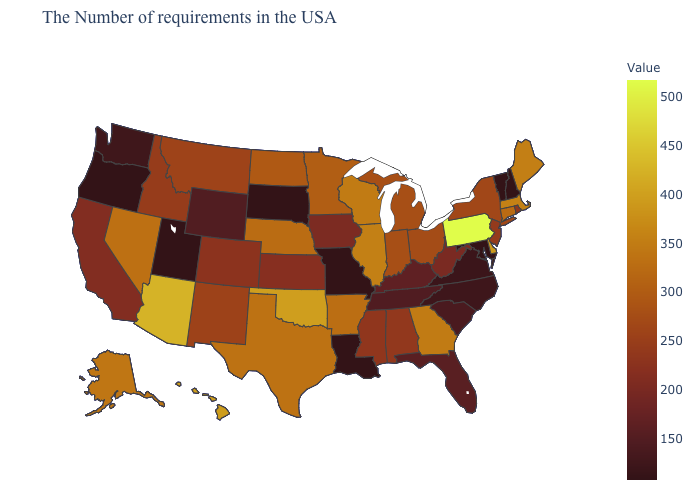Does the map have missing data?
Give a very brief answer. No. Which states have the lowest value in the Northeast?
Concise answer only. New Hampshire, Vermont. Does Delaware have the lowest value in the USA?
Keep it brief. No. Is the legend a continuous bar?
Keep it brief. Yes. Among the states that border Mississippi , which have the highest value?
Quick response, please. Arkansas. Which states have the lowest value in the USA?
Be succinct. New Hampshire, Vermont, Maryland, Louisiana, Missouri, South Dakota, Utah, Oregon. Does Utah have the lowest value in the USA?
Concise answer only. Yes. 